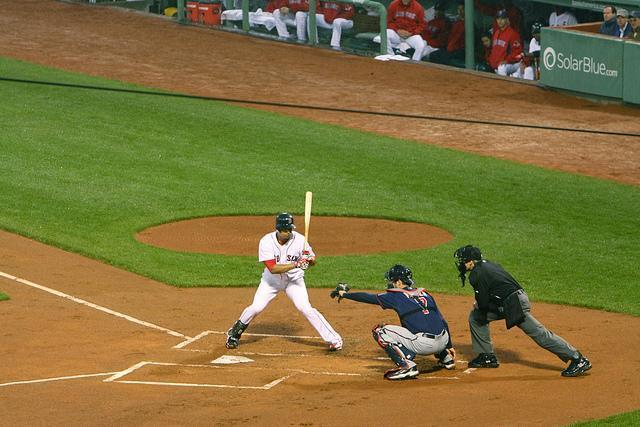How many players are on the field?
Give a very brief answer. 3. How many people are in the picture?
Give a very brief answer. 4. How many boats can you count?
Give a very brief answer. 0. 